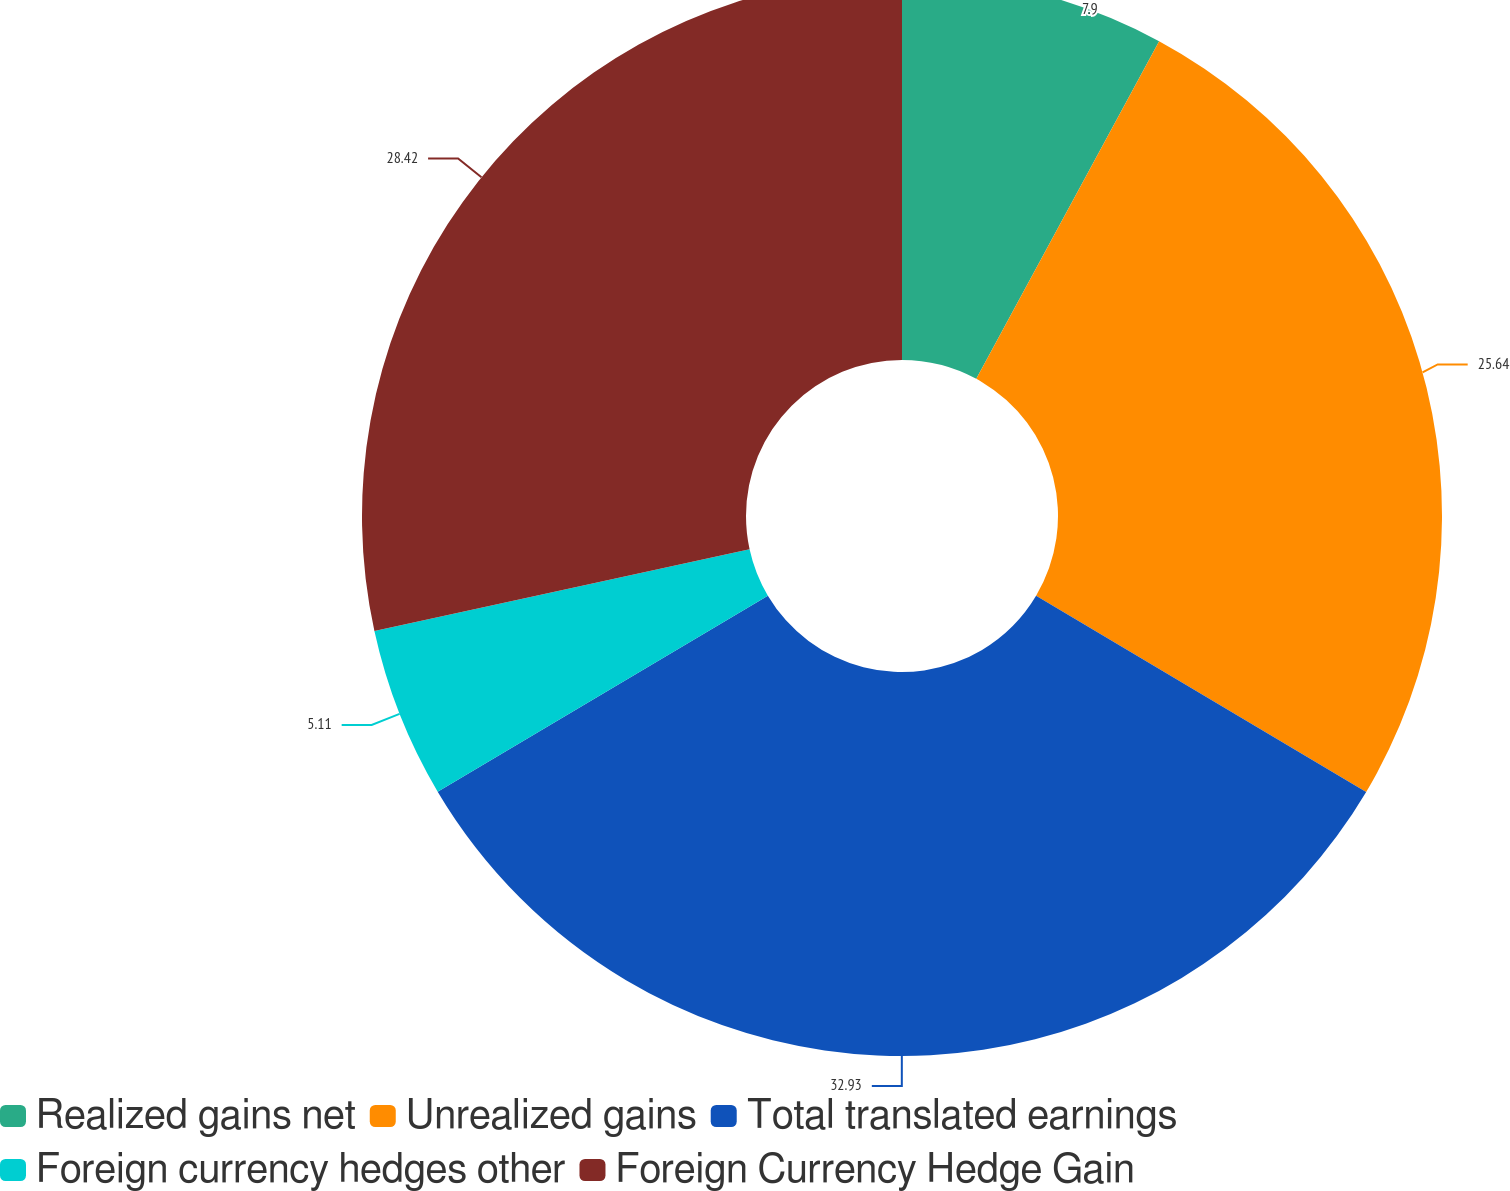<chart> <loc_0><loc_0><loc_500><loc_500><pie_chart><fcel>Realized gains net<fcel>Unrealized gains<fcel>Total translated earnings<fcel>Foreign currency hedges other<fcel>Foreign Currency Hedge Gain<nl><fcel>7.9%<fcel>25.64%<fcel>32.94%<fcel>5.11%<fcel>28.42%<nl></chart> 